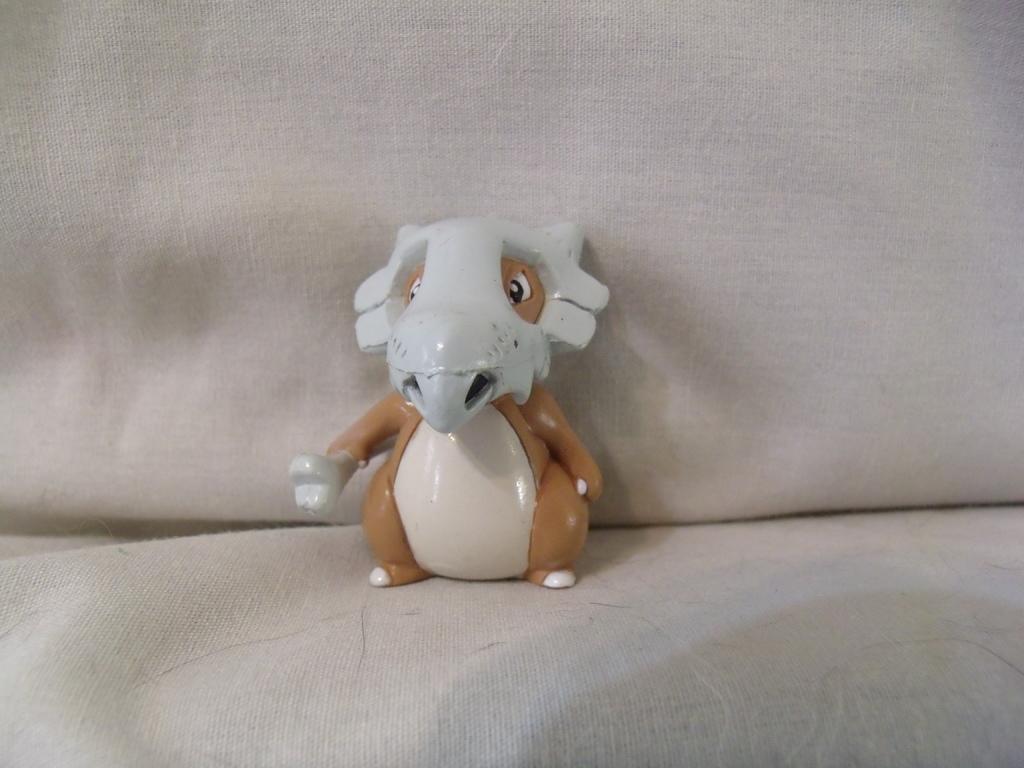Could you give a brief overview of what you see in this image? In this picture we can see a plastic toy of an animal kept on a sofa. 